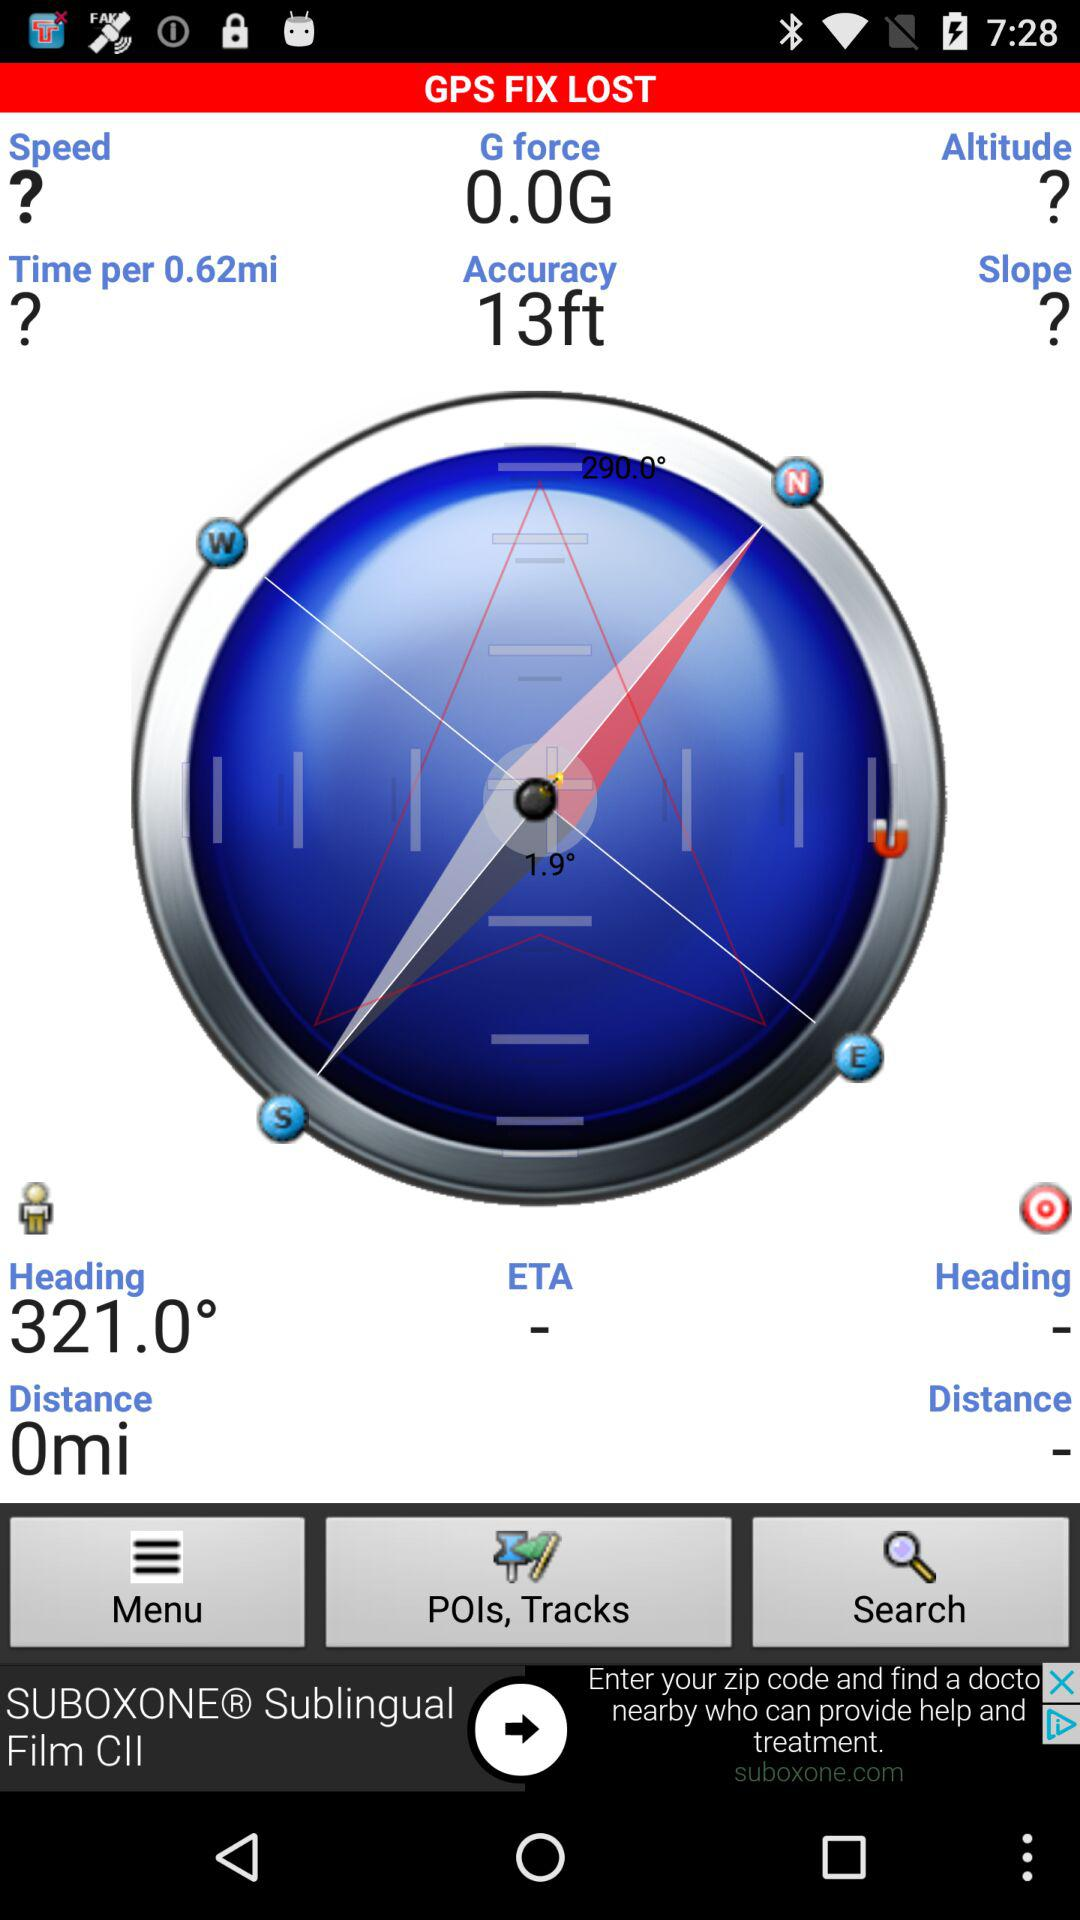What is the heading position of the user? The user's heading position is 321.0°. 